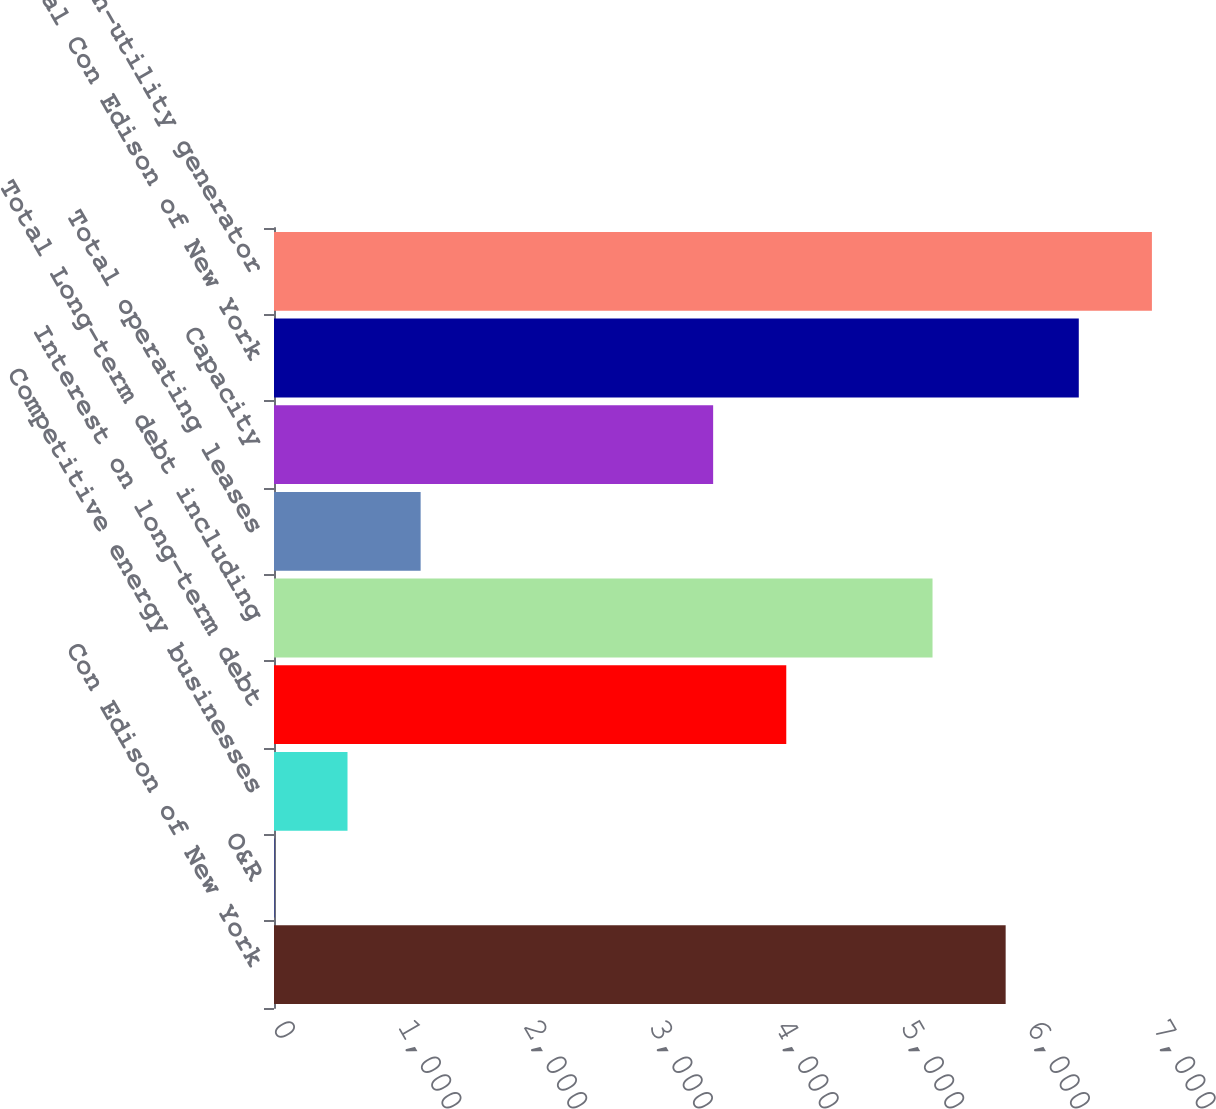Convert chart. <chart><loc_0><loc_0><loc_500><loc_500><bar_chart><fcel>Con Edison of New York<fcel>O&R<fcel>Competitive energy businesses<fcel>Interest on long-term debt<fcel>Total Long-term debt including<fcel>Total operating leases<fcel>Capacity<fcel>Total Con Edison of New York<fcel>Total non-utility generator<nl><fcel>5820<fcel>3<fcel>584.7<fcel>4074.9<fcel>5238.3<fcel>1166.4<fcel>3493.2<fcel>6401.7<fcel>6983.4<nl></chart> 